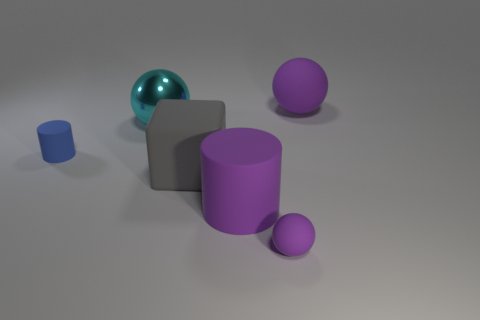Add 1 tiny red rubber cylinders. How many objects exist? 7 Subtract all cubes. How many objects are left? 5 Subtract all large green rubber balls. Subtract all blue cylinders. How many objects are left? 5 Add 2 cylinders. How many cylinders are left? 4 Add 5 large gray objects. How many large gray objects exist? 6 Subtract 0 cyan cylinders. How many objects are left? 6 